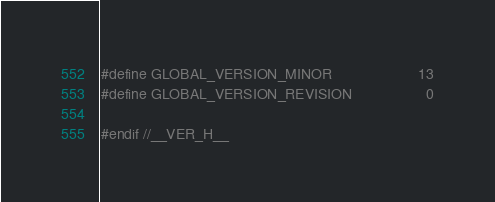Convert code to text. <code><loc_0><loc_0><loc_500><loc_500><_C_>#define GLOBAL_VERSION_MINOR                     13
#define GLOBAL_VERSION_REVISION                  0

#endif //__VER_H__
</code> 